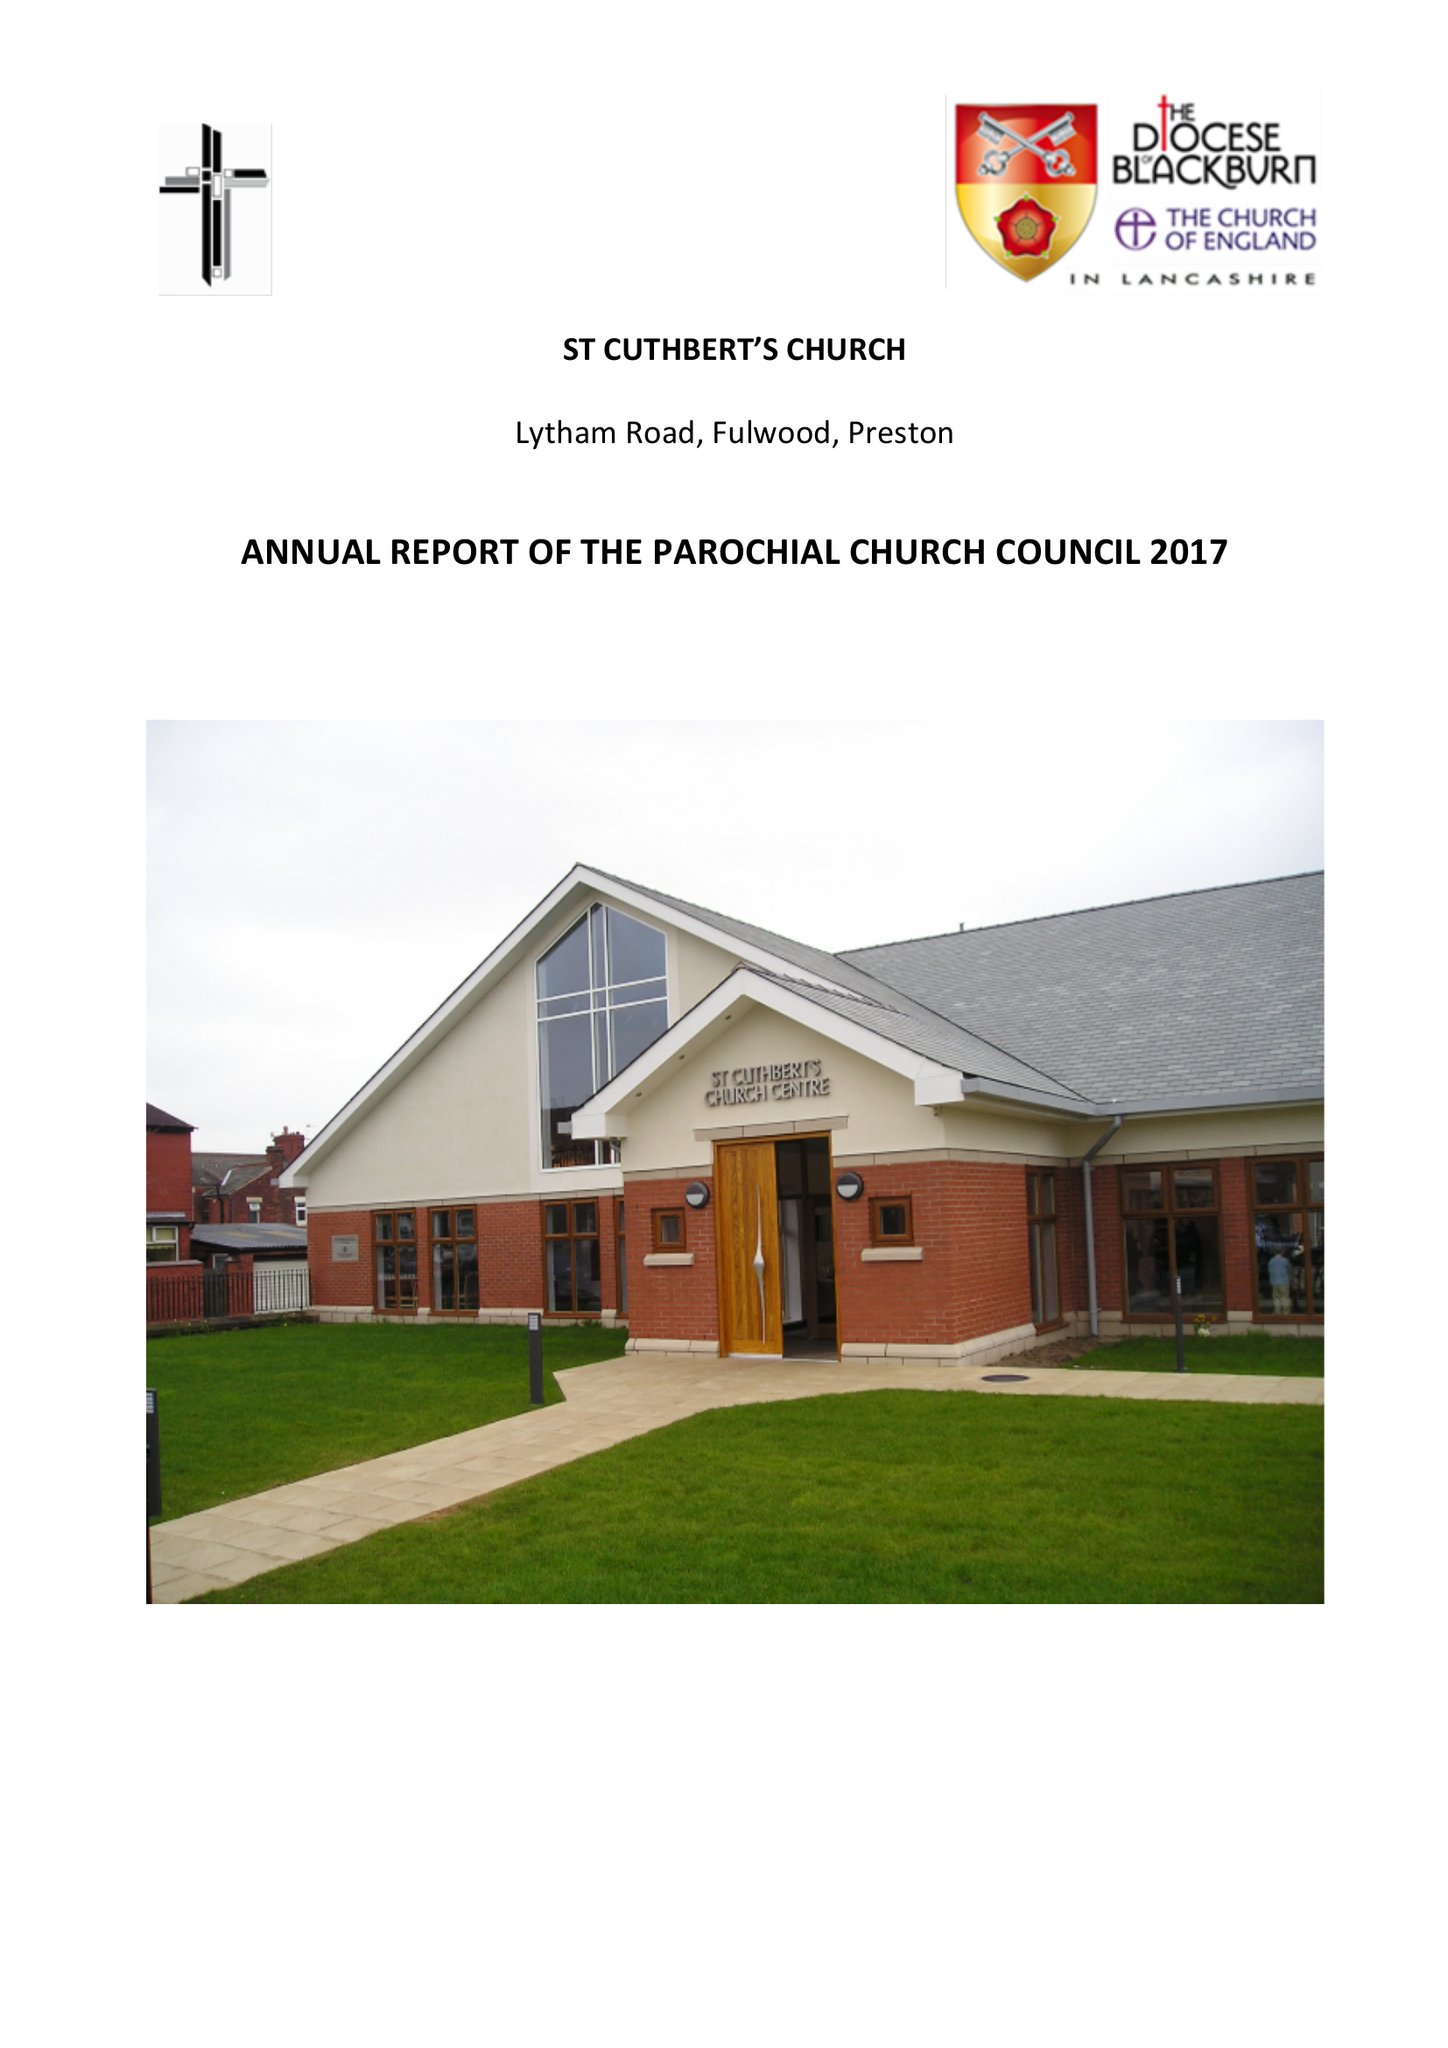What is the value for the report_date?
Answer the question using a single word or phrase. 2017-12-31 